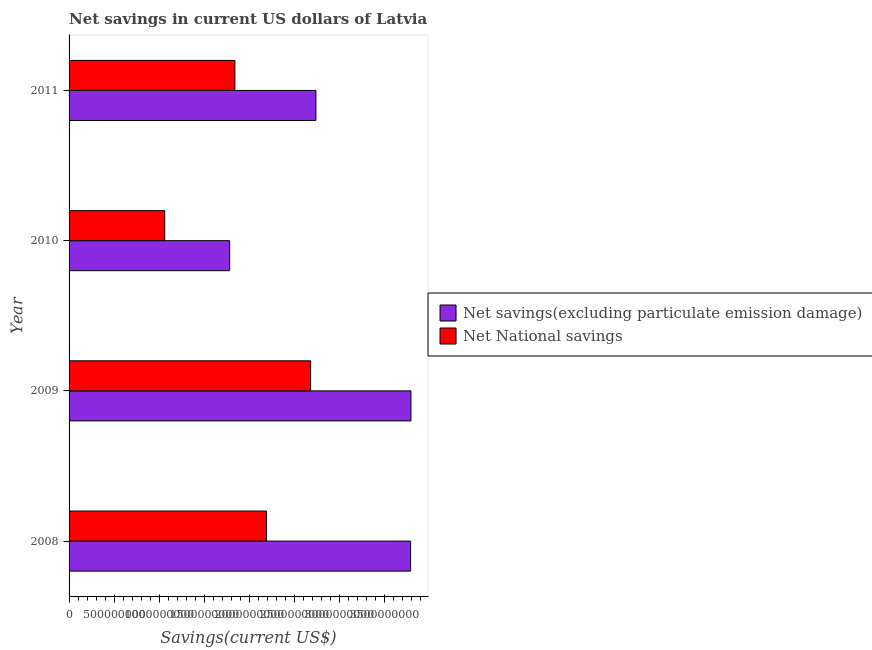How many groups of bars are there?
Offer a very short reply. 4. Are the number of bars on each tick of the Y-axis equal?
Your response must be concise. Yes. What is the label of the 2nd group of bars from the top?
Offer a very short reply. 2010. What is the net national savings in 2010?
Your response must be concise. 1.06e+09. Across all years, what is the maximum net savings(excluding particulate emission damage)?
Make the answer very short. 3.80e+09. Across all years, what is the minimum net national savings?
Offer a terse response. 1.06e+09. In which year was the net savings(excluding particulate emission damage) maximum?
Offer a terse response. 2009. What is the total net savings(excluding particulate emission damage) in the graph?
Keep it short and to the point. 1.21e+1. What is the difference between the net national savings in 2008 and that in 2010?
Provide a short and direct response. 1.13e+09. What is the difference between the net national savings in 2009 and the net savings(excluding particulate emission damage) in 2008?
Provide a short and direct response. -1.11e+09. What is the average net savings(excluding particulate emission damage) per year?
Offer a very short reply. 3.03e+09. In the year 2008, what is the difference between the net savings(excluding particulate emission damage) and net national savings?
Provide a short and direct response. 1.60e+09. What is the ratio of the net savings(excluding particulate emission damage) in 2009 to that in 2010?
Provide a short and direct response. 2.13. Is the net national savings in 2008 less than that in 2011?
Provide a short and direct response. No. Is the difference between the net national savings in 2008 and 2011 greater than the difference between the net savings(excluding particulate emission damage) in 2008 and 2011?
Keep it short and to the point. No. What is the difference between the highest and the second highest net savings(excluding particulate emission damage)?
Ensure brevity in your answer.  3.63e+06. What is the difference between the highest and the lowest net national savings?
Your answer should be compact. 1.62e+09. What does the 2nd bar from the top in 2010 represents?
Ensure brevity in your answer.  Net savings(excluding particulate emission damage). What does the 2nd bar from the bottom in 2008 represents?
Provide a succinct answer. Net National savings. What is the difference between two consecutive major ticks on the X-axis?
Your response must be concise. 5.00e+08. Are the values on the major ticks of X-axis written in scientific E-notation?
Offer a terse response. No. Does the graph contain any zero values?
Make the answer very short. No. Does the graph contain grids?
Provide a succinct answer. No. How are the legend labels stacked?
Your response must be concise. Vertical. What is the title of the graph?
Ensure brevity in your answer.  Net savings in current US dollars of Latvia. Does "Males" appear as one of the legend labels in the graph?
Give a very brief answer. No. What is the label or title of the X-axis?
Provide a succinct answer. Savings(current US$). What is the Savings(current US$) of Net savings(excluding particulate emission damage) in 2008?
Your answer should be very brief. 3.79e+09. What is the Savings(current US$) in Net National savings in 2008?
Give a very brief answer. 2.19e+09. What is the Savings(current US$) of Net savings(excluding particulate emission damage) in 2009?
Keep it short and to the point. 3.80e+09. What is the Savings(current US$) of Net National savings in 2009?
Offer a terse response. 2.68e+09. What is the Savings(current US$) of Net savings(excluding particulate emission damage) in 2010?
Make the answer very short. 1.78e+09. What is the Savings(current US$) of Net National savings in 2010?
Make the answer very short. 1.06e+09. What is the Savings(current US$) of Net savings(excluding particulate emission damage) in 2011?
Your answer should be very brief. 2.74e+09. What is the Savings(current US$) in Net National savings in 2011?
Your answer should be very brief. 1.84e+09. Across all years, what is the maximum Savings(current US$) of Net savings(excluding particulate emission damage)?
Ensure brevity in your answer.  3.80e+09. Across all years, what is the maximum Savings(current US$) of Net National savings?
Ensure brevity in your answer.  2.68e+09. Across all years, what is the minimum Savings(current US$) in Net savings(excluding particulate emission damage)?
Your answer should be very brief. 1.78e+09. Across all years, what is the minimum Savings(current US$) of Net National savings?
Give a very brief answer. 1.06e+09. What is the total Savings(current US$) in Net savings(excluding particulate emission damage) in the graph?
Your response must be concise. 1.21e+1. What is the total Savings(current US$) of Net National savings in the graph?
Offer a very short reply. 7.78e+09. What is the difference between the Savings(current US$) of Net savings(excluding particulate emission damage) in 2008 and that in 2009?
Provide a succinct answer. -3.63e+06. What is the difference between the Savings(current US$) in Net National savings in 2008 and that in 2009?
Provide a short and direct response. -4.90e+08. What is the difference between the Savings(current US$) in Net savings(excluding particulate emission damage) in 2008 and that in 2010?
Your answer should be very brief. 2.01e+09. What is the difference between the Savings(current US$) in Net National savings in 2008 and that in 2010?
Your response must be concise. 1.13e+09. What is the difference between the Savings(current US$) in Net savings(excluding particulate emission damage) in 2008 and that in 2011?
Provide a succinct answer. 1.05e+09. What is the difference between the Savings(current US$) of Net National savings in 2008 and that in 2011?
Your answer should be compact. 3.51e+08. What is the difference between the Savings(current US$) in Net savings(excluding particulate emission damage) in 2009 and that in 2010?
Offer a terse response. 2.01e+09. What is the difference between the Savings(current US$) in Net National savings in 2009 and that in 2010?
Provide a short and direct response. 1.62e+09. What is the difference between the Savings(current US$) in Net savings(excluding particulate emission damage) in 2009 and that in 2011?
Keep it short and to the point. 1.06e+09. What is the difference between the Savings(current US$) in Net National savings in 2009 and that in 2011?
Provide a short and direct response. 8.41e+08. What is the difference between the Savings(current US$) in Net savings(excluding particulate emission damage) in 2010 and that in 2011?
Your response must be concise. -9.58e+08. What is the difference between the Savings(current US$) in Net National savings in 2010 and that in 2011?
Keep it short and to the point. -7.79e+08. What is the difference between the Savings(current US$) in Net savings(excluding particulate emission damage) in 2008 and the Savings(current US$) in Net National savings in 2009?
Offer a very short reply. 1.11e+09. What is the difference between the Savings(current US$) in Net savings(excluding particulate emission damage) in 2008 and the Savings(current US$) in Net National savings in 2010?
Offer a terse response. 2.73e+09. What is the difference between the Savings(current US$) in Net savings(excluding particulate emission damage) in 2008 and the Savings(current US$) in Net National savings in 2011?
Give a very brief answer. 1.95e+09. What is the difference between the Savings(current US$) of Net savings(excluding particulate emission damage) in 2009 and the Savings(current US$) of Net National savings in 2010?
Ensure brevity in your answer.  2.73e+09. What is the difference between the Savings(current US$) in Net savings(excluding particulate emission damage) in 2009 and the Savings(current US$) in Net National savings in 2011?
Provide a short and direct response. 1.96e+09. What is the difference between the Savings(current US$) of Net savings(excluding particulate emission damage) in 2010 and the Savings(current US$) of Net National savings in 2011?
Your answer should be compact. -5.80e+07. What is the average Savings(current US$) in Net savings(excluding particulate emission damage) per year?
Offer a very short reply. 3.03e+09. What is the average Savings(current US$) of Net National savings per year?
Provide a succinct answer. 1.95e+09. In the year 2008, what is the difference between the Savings(current US$) of Net savings(excluding particulate emission damage) and Savings(current US$) of Net National savings?
Your answer should be compact. 1.60e+09. In the year 2009, what is the difference between the Savings(current US$) of Net savings(excluding particulate emission damage) and Savings(current US$) of Net National savings?
Keep it short and to the point. 1.11e+09. In the year 2010, what is the difference between the Savings(current US$) in Net savings(excluding particulate emission damage) and Savings(current US$) in Net National savings?
Give a very brief answer. 7.21e+08. In the year 2011, what is the difference between the Savings(current US$) of Net savings(excluding particulate emission damage) and Savings(current US$) of Net National savings?
Your response must be concise. 9.00e+08. What is the ratio of the Savings(current US$) in Net National savings in 2008 to that in 2009?
Offer a very short reply. 0.82. What is the ratio of the Savings(current US$) in Net savings(excluding particulate emission damage) in 2008 to that in 2010?
Make the answer very short. 2.13. What is the ratio of the Savings(current US$) of Net National savings in 2008 to that in 2010?
Provide a short and direct response. 2.06. What is the ratio of the Savings(current US$) in Net savings(excluding particulate emission damage) in 2008 to that in 2011?
Your answer should be compact. 1.38. What is the ratio of the Savings(current US$) of Net National savings in 2008 to that in 2011?
Ensure brevity in your answer.  1.19. What is the ratio of the Savings(current US$) of Net savings(excluding particulate emission damage) in 2009 to that in 2010?
Ensure brevity in your answer.  2.13. What is the ratio of the Savings(current US$) of Net National savings in 2009 to that in 2010?
Your response must be concise. 2.52. What is the ratio of the Savings(current US$) in Net savings(excluding particulate emission damage) in 2009 to that in 2011?
Your answer should be compact. 1.38. What is the ratio of the Savings(current US$) in Net National savings in 2009 to that in 2011?
Your response must be concise. 1.46. What is the ratio of the Savings(current US$) in Net savings(excluding particulate emission damage) in 2010 to that in 2011?
Provide a short and direct response. 0.65. What is the ratio of the Savings(current US$) of Net National savings in 2010 to that in 2011?
Provide a succinct answer. 0.58. What is the difference between the highest and the second highest Savings(current US$) in Net savings(excluding particulate emission damage)?
Provide a short and direct response. 3.63e+06. What is the difference between the highest and the second highest Savings(current US$) of Net National savings?
Offer a very short reply. 4.90e+08. What is the difference between the highest and the lowest Savings(current US$) of Net savings(excluding particulate emission damage)?
Your answer should be compact. 2.01e+09. What is the difference between the highest and the lowest Savings(current US$) in Net National savings?
Ensure brevity in your answer.  1.62e+09. 